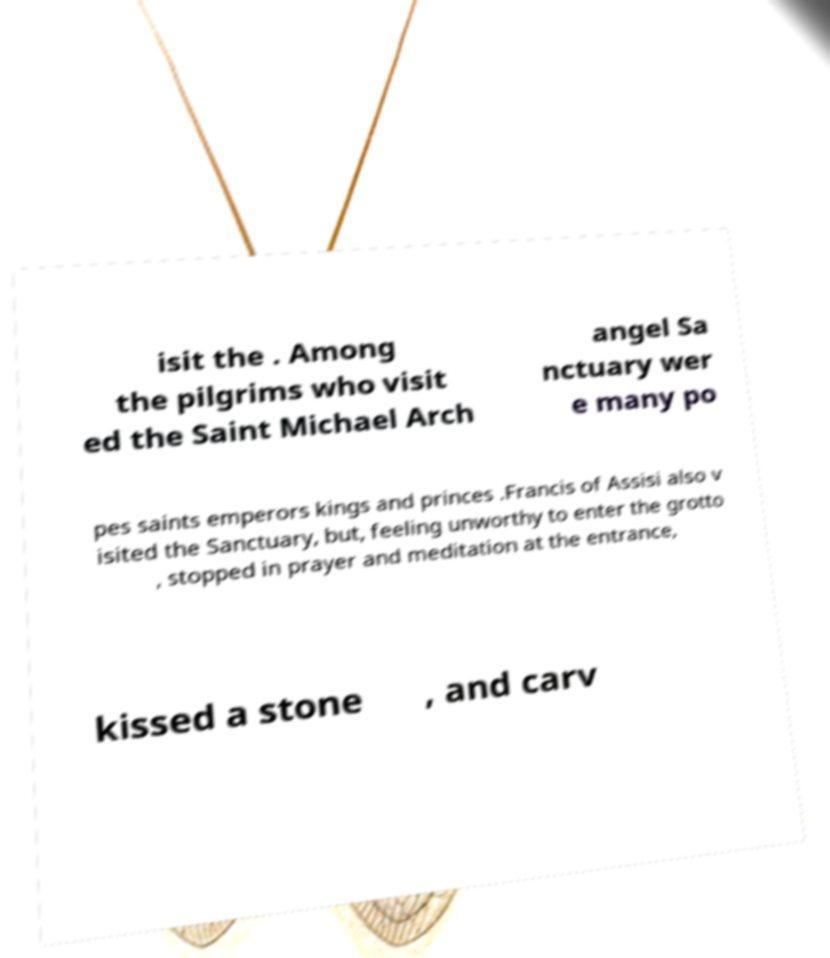Please identify and transcribe the text found in this image. isit the . Among the pilgrims who visit ed the Saint Michael Arch angel Sa nctuary wer e many po pes saints emperors kings and princes .Francis of Assisi also v isited the Sanctuary, but, feeling unworthy to enter the grotto , stopped in prayer and meditation at the entrance, kissed a stone , and carv 